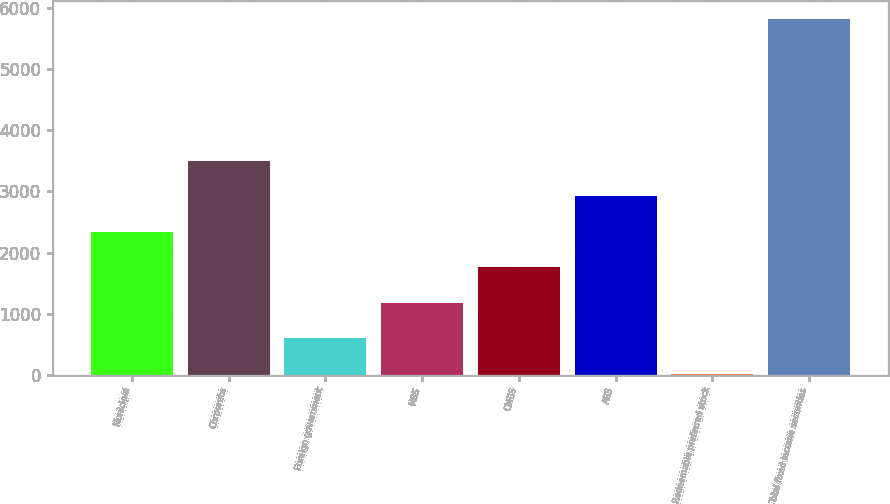<chart> <loc_0><loc_0><loc_500><loc_500><bar_chart><fcel>Municipal<fcel>Corporate<fcel>Foreign government<fcel>MBS<fcel>CMBS<fcel>ABS<fcel>Redeemable preferred stock<fcel>Total fixed income securities<nl><fcel>2338.2<fcel>3500.8<fcel>594.3<fcel>1175.6<fcel>1756.9<fcel>2919.5<fcel>13<fcel>5826<nl></chart> 